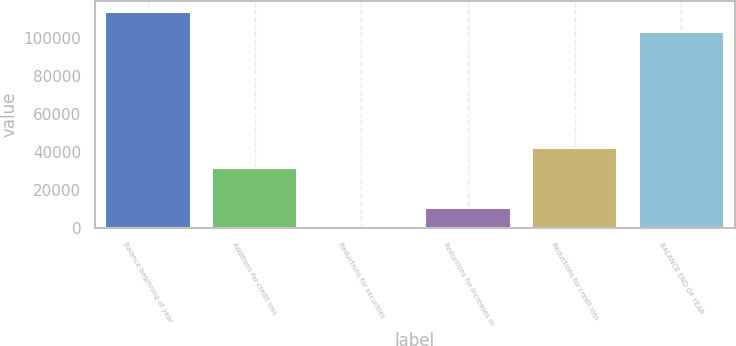<chart> <loc_0><loc_0><loc_500><loc_500><bar_chart><fcel>Balance beginning of year<fcel>Additions for credit loss<fcel>Reductions for securities<fcel>Reductions for increases in<fcel>Reductions for credit loss<fcel>BALANCE END OF YEAR<nl><fcel>113614<fcel>31573.6<fcel>0.2<fcel>10524.7<fcel>42098.1<fcel>103090<nl></chart> 